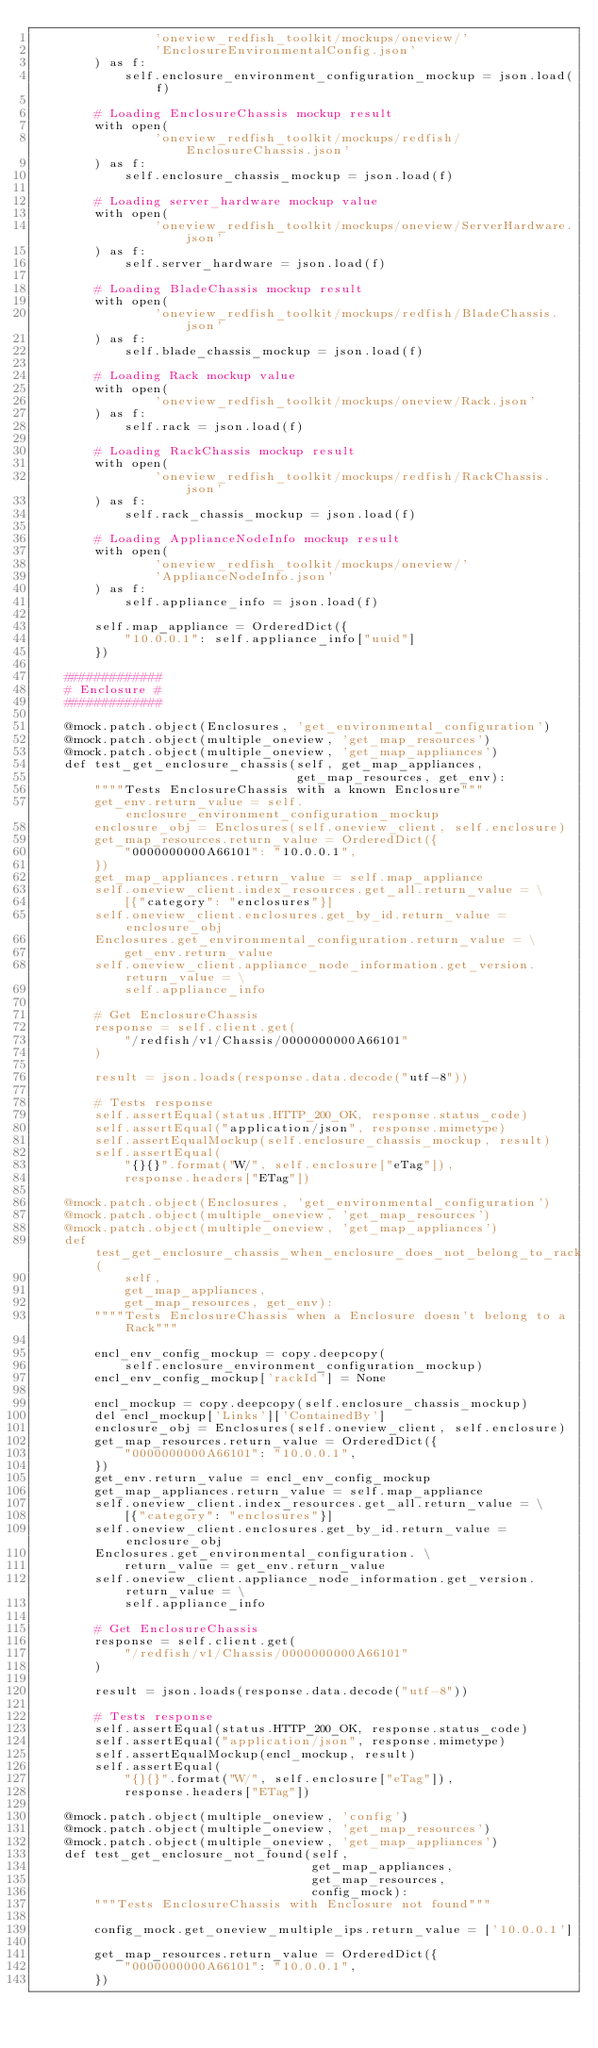Convert code to text. <code><loc_0><loc_0><loc_500><loc_500><_Python_>                'oneview_redfish_toolkit/mockups/oneview/'
                'EnclosureEnvironmentalConfig.json'
        ) as f:
            self.enclosure_environment_configuration_mockup = json.load(f)

        # Loading EnclosureChassis mockup result
        with open(
                'oneview_redfish_toolkit/mockups/redfish/EnclosureChassis.json'
        ) as f:
            self.enclosure_chassis_mockup = json.load(f)

        # Loading server_hardware mockup value
        with open(
                'oneview_redfish_toolkit/mockups/oneview/ServerHardware.json'
        ) as f:
            self.server_hardware = json.load(f)

        # Loading BladeChassis mockup result
        with open(
                'oneview_redfish_toolkit/mockups/redfish/BladeChassis.json'
        ) as f:
            self.blade_chassis_mockup = json.load(f)

        # Loading Rack mockup value
        with open(
                'oneview_redfish_toolkit/mockups/oneview/Rack.json'
        ) as f:
            self.rack = json.load(f)

        # Loading RackChassis mockup result
        with open(
                'oneview_redfish_toolkit/mockups/redfish/RackChassis.json'
        ) as f:
            self.rack_chassis_mockup = json.load(f)

        # Loading ApplianceNodeInfo mockup result
        with open(
                'oneview_redfish_toolkit/mockups/oneview/'
                'ApplianceNodeInfo.json'
        ) as f:
            self.appliance_info = json.load(f)

        self.map_appliance = OrderedDict({
            "10.0.0.1": self.appliance_info["uuid"]
        })

    #############
    # Enclosure #
    #############

    @mock.patch.object(Enclosures, 'get_environmental_configuration')
    @mock.patch.object(multiple_oneview, 'get_map_resources')
    @mock.patch.object(multiple_oneview, 'get_map_appliances')
    def test_get_enclosure_chassis(self, get_map_appliances,
                                   get_map_resources, get_env):
        """"Tests EnclosureChassis with a known Enclosure"""
        get_env.return_value = self.enclosure_environment_configuration_mockup
        enclosure_obj = Enclosures(self.oneview_client, self.enclosure)
        get_map_resources.return_value = OrderedDict({
            "0000000000A66101": "10.0.0.1",
        })
        get_map_appliances.return_value = self.map_appliance
        self.oneview_client.index_resources.get_all.return_value = \
            [{"category": "enclosures"}]
        self.oneview_client.enclosures.get_by_id.return_value = enclosure_obj
        Enclosures.get_environmental_configuration.return_value = \
            get_env.return_value
        self.oneview_client.appliance_node_information.get_version.return_value = \
            self.appliance_info

        # Get EnclosureChassis
        response = self.client.get(
            "/redfish/v1/Chassis/0000000000A66101"
        )

        result = json.loads(response.data.decode("utf-8"))

        # Tests response
        self.assertEqual(status.HTTP_200_OK, response.status_code)
        self.assertEqual("application/json", response.mimetype)
        self.assertEqualMockup(self.enclosure_chassis_mockup, result)
        self.assertEqual(
            "{}{}".format("W/", self.enclosure["eTag"]),
            response.headers["ETag"])

    @mock.patch.object(Enclosures, 'get_environmental_configuration')
    @mock.patch.object(multiple_oneview, 'get_map_resources')
    @mock.patch.object(multiple_oneview, 'get_map_appliances')
    def test_get_enclosure_chassis_when_enclosure_does_not_belong_to_rack(
            self,
            get_map_appliances,
            get_map_resources, get_env):
        """"Tests EnclosureChassis when a Enclosure doesn't belong to a Rack"""

        encl_env_config_mockup = copy.deepcopy(
            self.enclosure_environment_configuration_mockup)
        encl_env_config_mockup['rackId'] = None

        encl_mockup = copy.deepcopy(self.enclosure_chassis_mockup)
        del encl_mockup['Links']['ContainedBy']
        enclosure_obj = Enclosures(self.oneview_client, self.enclosure)
        get_map_resources.return_value = OrderedDict({
            "0000000000A66101": "10.0.0.1",
        })
        get_env.return_value = encl_env_config_mockup
        get_map_appliances.return_value = self.map_appliance
        self.oneview_client.index_resources.get_all.return_value = \
            [{"category": "enclosures"}]
        self.oneview_client.enclosures.get_by_id.return_value = enclosure_obj
        Enclosures.get_environmental_configuration. \
            return_value = get_env.return_value
        self.oneview_client.appliance_node_information.get_version.return_value = \
            self.appliance_info

        # Get EnclosureChassis
        response = self.client.get(
            "/redfish/v1/Chassis/0000000000A66101"
        )

        result = json.loads(response.data.decode("utf-8"))

        # Tests response
        self.assertEqual(status.HTTP_200_OK, response.status_code)
        self.assertEqual("application/json", response.mimetype)
        self.assertEqualMockup(encl_mockup, result)
        self.assertEqual(
            "{}{}".format("W/", self.enclosure["eTag"]),
            response.headers["ETag"])

    @mock.patch.object(multiple_oneview, 'config')
    @mock.patch.object(multiple_oneview, 'get_map_resources')
    @mock.patch.object(multiple_oneview, 'get_map_appliances')
    def test_get_enclosure_not_found(self,
                                     get_map_appliances,
                                     get_map_resources,
                                     config_mock):
        """Tests EnclosureChassis with Enclosure not found"""

        config_mock.get_oneview_multiple_ips.return_value = ['10.0.0.1']

        get_map_resources.return_value = OrderedDict({
            "0000000000A66101": "10.0.0.1",
        })</code> 